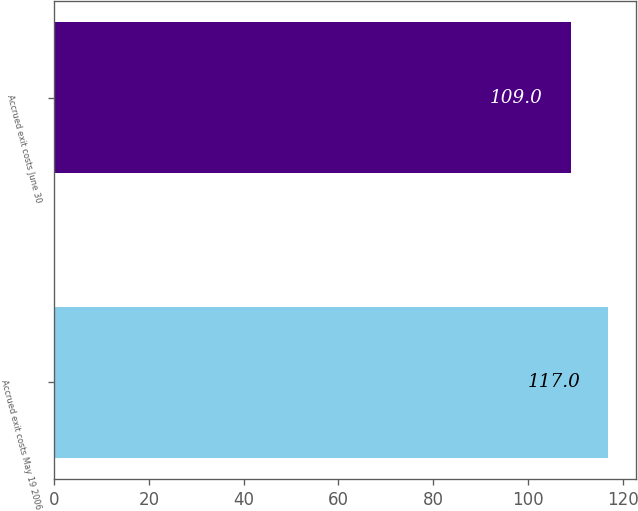Convert chart. <chart><loc_0><loc_0><loc_500><loc_500><bar_chart><fcel>Accrued exit costs May 19 2006<fcel>Accrued exit costs June 30<nl><fcel>117<fcel>109<nl></chart> 